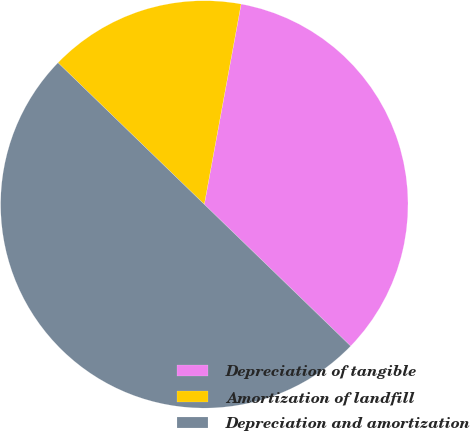Convert chart. <chart><loc_0><loc_0><loc_500><loc_500><pie_chart><fcel>Depreciation of tangible<fcel>Amortization of landfill<fcel>Depreciation and amortization<nl><fcel>34.35%<fcel>15.65%<fcel>50.0%<nl></chart> 